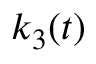<formula> <loc_0><loc_0><loc_500><loc_500>k _ { 3 } ( t )</formula> 